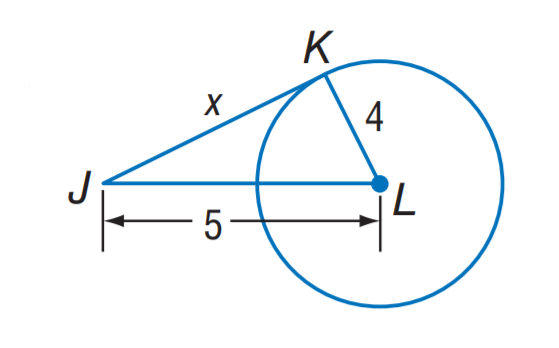Question: The segment is tangent to the circle. Find x.
Choices:
A. 2
B. 3
C. 4
D. 5
Answer with the letter. Answer: B 